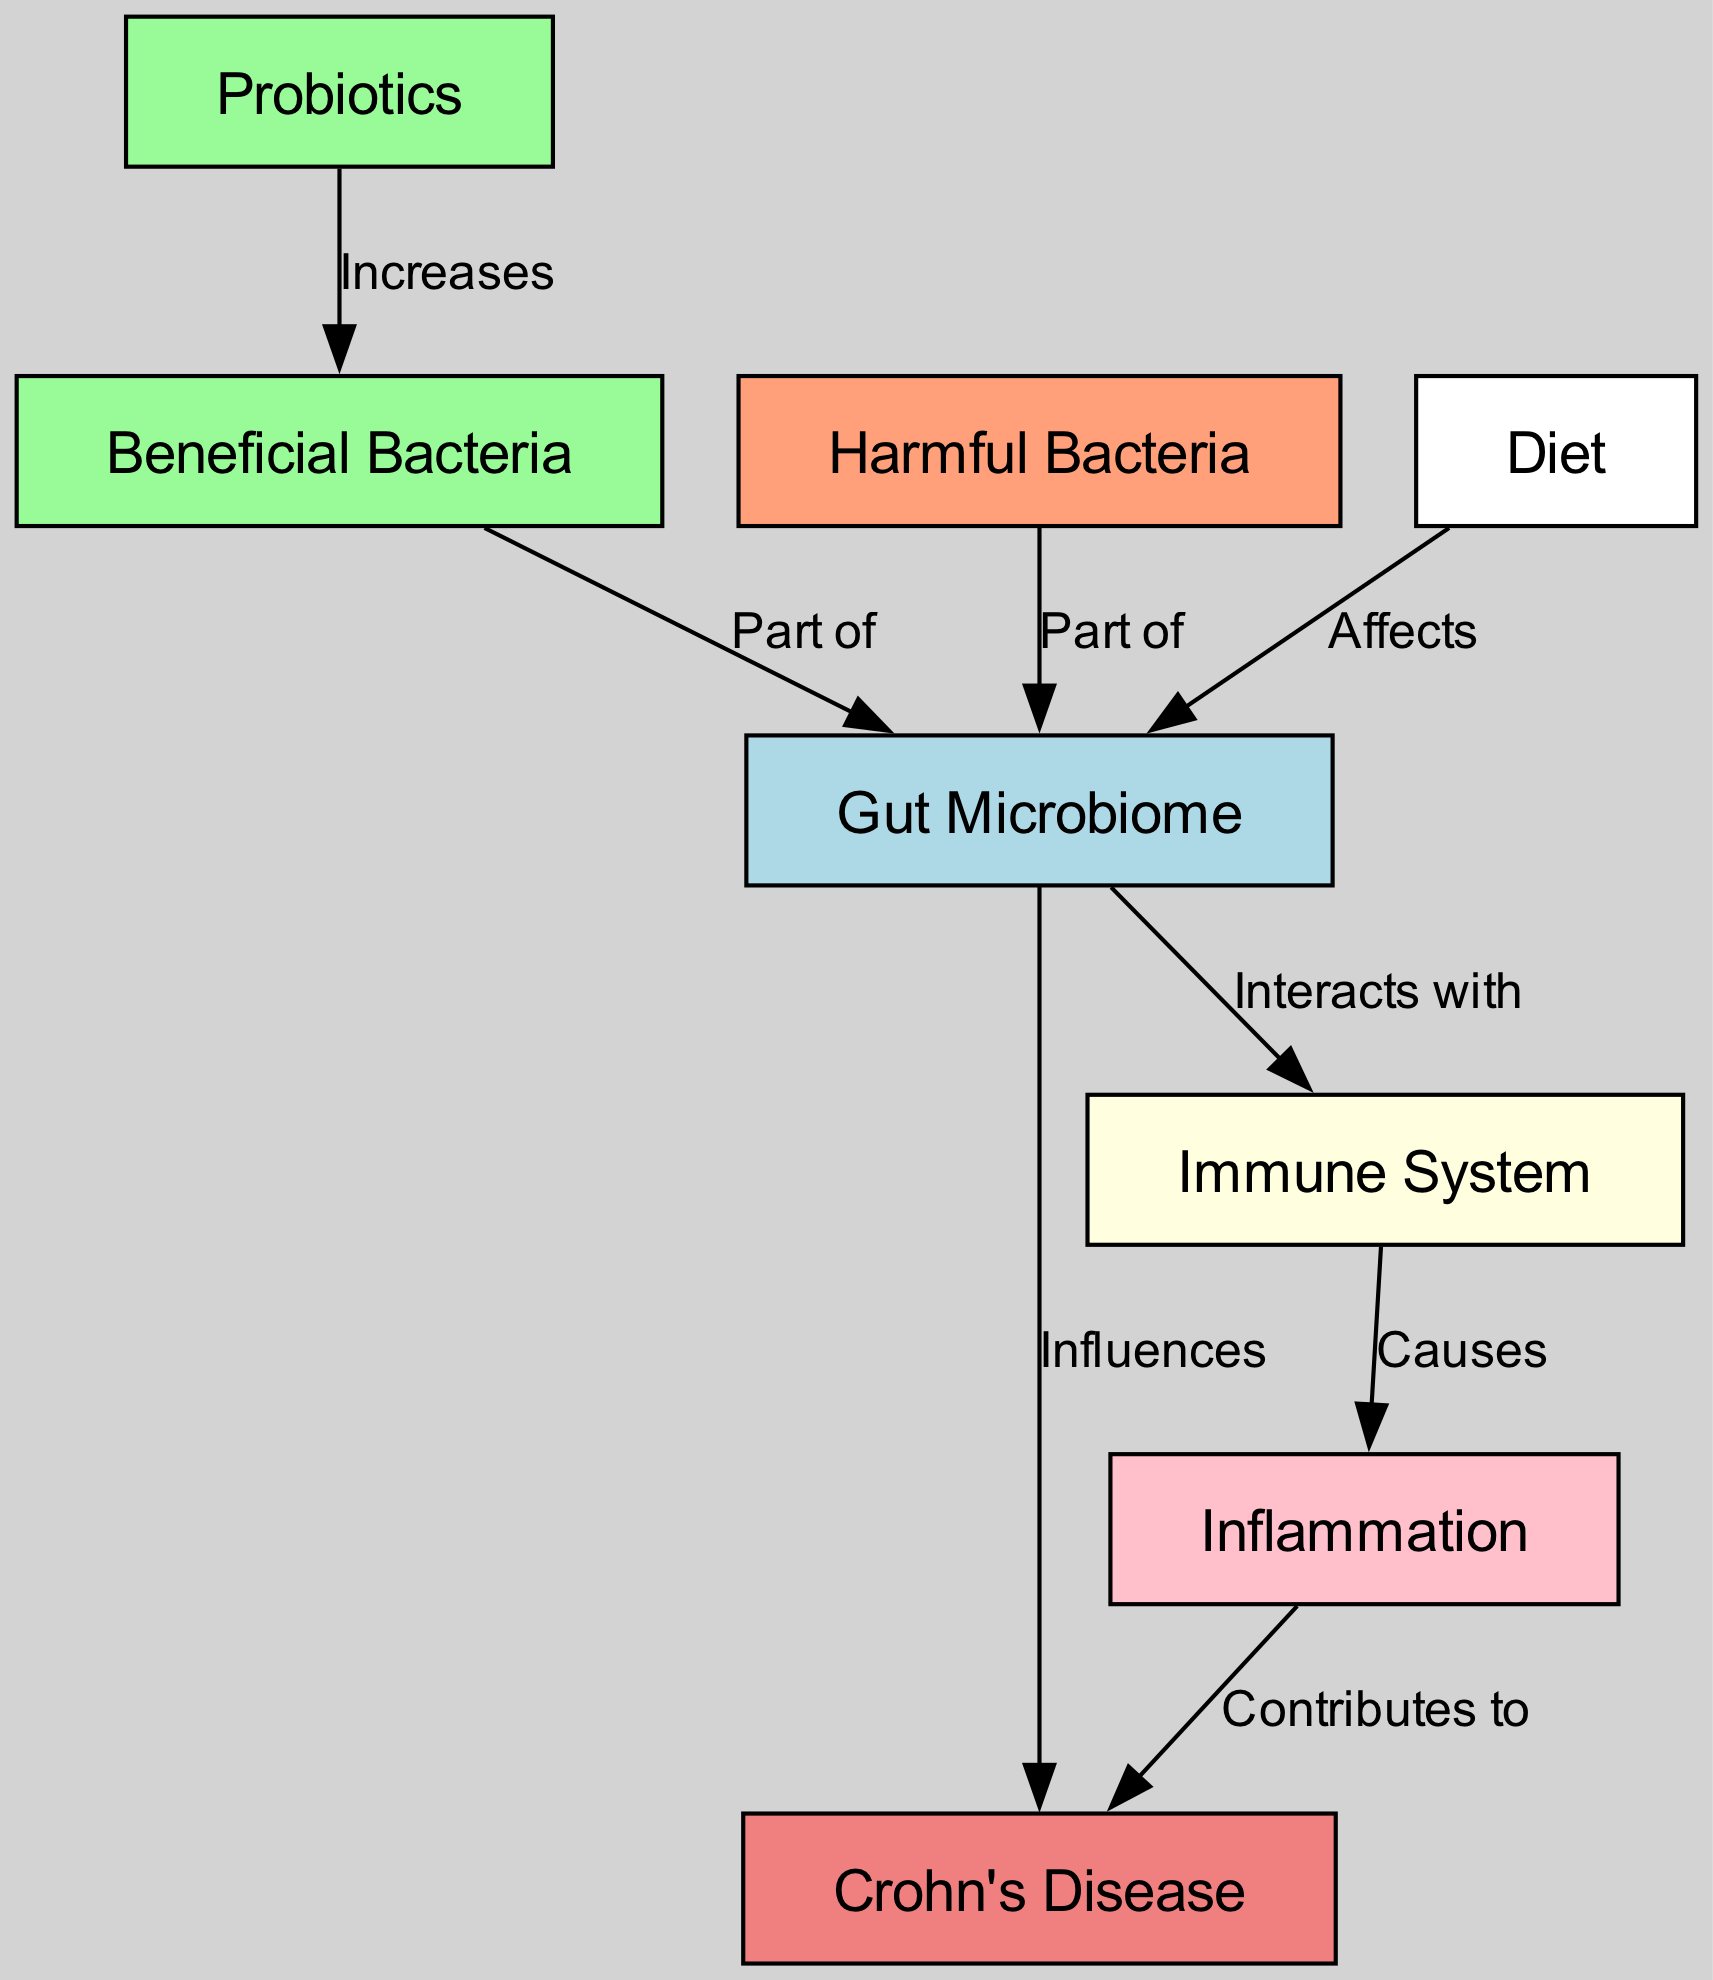What influences Crohn's Disease? According to the diagram, the Gut Microbiome influences Crohn's Disease directly. This relationship is shown explicitly with an edge labeled "Influences" from the Gut Microbiome to Crohn's Disease.
Answer: Gut Microbiome How many nodes are in the diagram? The diagram contains a total of 8 nodes, each representing different entities related to the gut microbiome and Crohn's disease as identified in the data provided.
Answer: 8 What type of bacteria is part of the Gut Microbiome? The diagram shows both Beneficial Bacteria and Harmful Bacteria as parts of the Gut Microbiome. This is indicated by edges labeled "Part of" connecting these entities to the Gut Microbiome node.
Answer: Beneficial Bacteria and Harmful Bacteria What does the Immune System cause? The diagram indicates that the Immune System causes Inflammation. This is shown with an edge labeled "Causes" directed from the Immune System to the Inflammation node.
Answer: Inflammation What affects the Gut Microbiome? The diagram indicates that Diet affects the Gut Microbiome, as shown by an edge labeled "Affects" that connects the Diet node to the Gut Microbiome.
Answer: Diet What increases Beneficial Bacteria? The diagram illustrates that Probiotics increases Beneficial Bacteria. This is depicted by an edge labeled "Increases" going from the Probiotics node to the Beneficial Bacteria node.
Answer: Probiotics How does Inflammation contribute to Crohn's Disease? According to the diagram, Inflammation contributes to Crohn's Disease directly, as indicated by an edge labeled "Contributes to" connecting Inflammation to Crohn's Disease.
Answer: Contributes to What is the relationship between the Gut Microbiome and the Immune System? The diagram illustrates that the Gut Microbiome interacts with the Immune System, indicated by an edge labeled "Interacts with" connecting these two nodes.
Answer: Interacts with What role does Diet play in relation to the Gut Microbiome? The diagram shows that Diet affects the Gut Microbiome, as represented by an edge labeled "Affects" going from the Diet node to the Gut Microbiome node.
Answer: Affects 